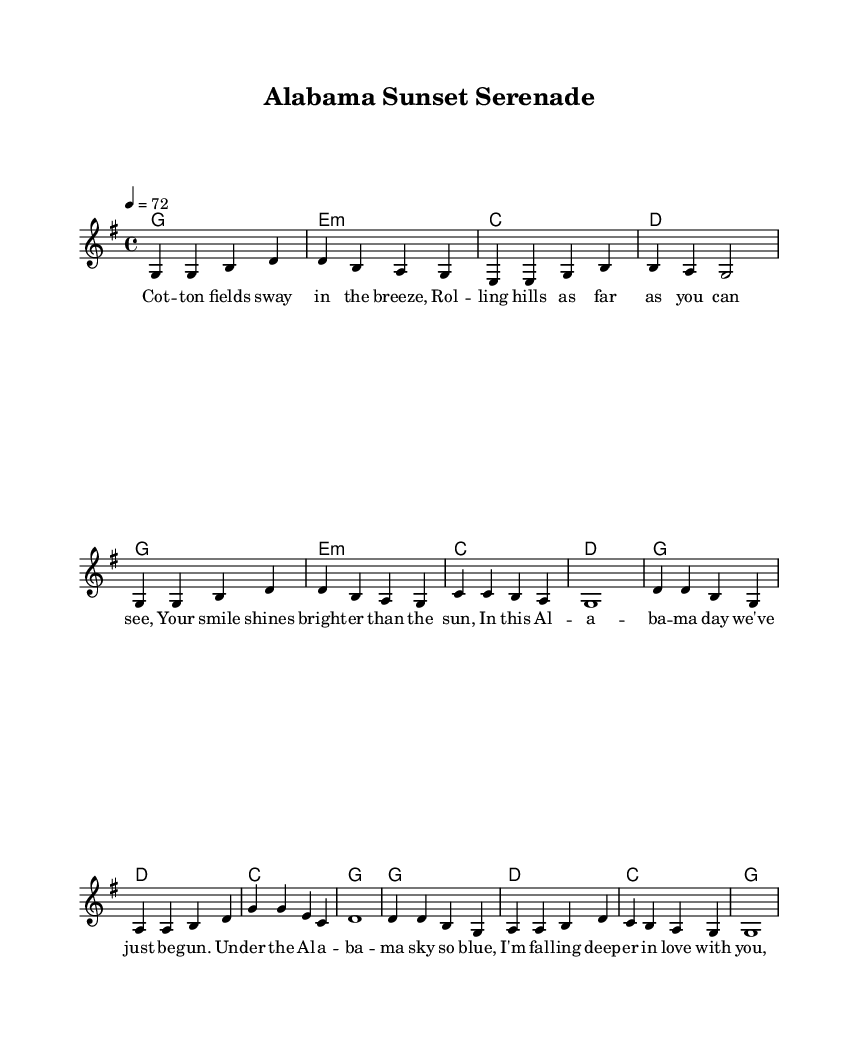What is the key signature of this music? The key signature indicated in the music is G major, which has one sharp (F#). This can be confirmed by looking at the staff, where the sharp is placed.
Answer: G major What is the time signature of this music? The time signature shown in the sheet music is 4/4, which is represented at the beginning of the score. This means there are four beats in each measure, and the quarter note gets one beat.
Answer: 4/4 What is the tempo marking of this piece? The tempo marking in the score states "4 = 72," indicating that the quarter note should be played at a speed of 72 beats per minute. This is found in the tempo indication section of the music.
Answer: 72 How many verses are in this song? There are two verses as indicated in the structure of the melody. Each verse is followed by repeated chorus sections, which can be noted in the format of the lyrics provided.
Answer: 2 What is the primary theme of the lyrics in this song? The primary theme focuses on love set against the beautiful landscape of Alabama, as portrayed through words depicting nature and affection in the lyrics. This theme can be derived from the imagery and sentiments expressed in both the verse and chorus.
Answer: Love Which chord is repeated the most in the chorus? The chord "G" is repeated multiple times throughout the chorus, which can be checked by reviewing the chord progressions listed for the chorus section.
Answer: G What landscape is invoked in the lyrics of this song? The lyrics mention "cotton fields" and "rolling hills," which clearly reference the Alabama landscape. These elements are explicitly stated in the verses as part of the descriptive imagery used.
Answer: Alabama landscape 